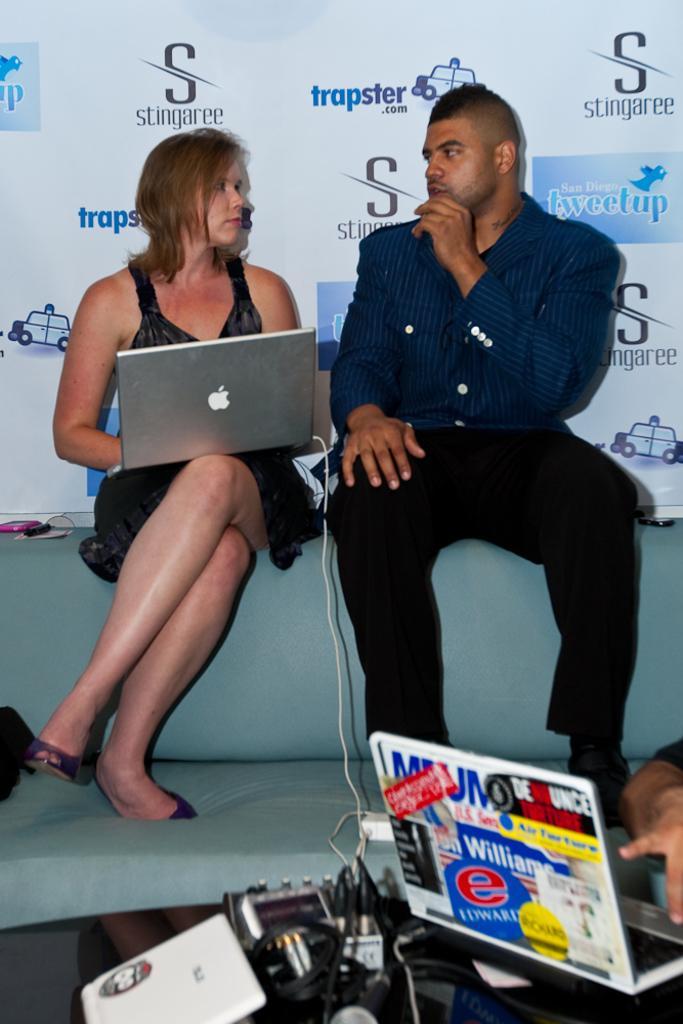Can you describe this image briefly? At the bottom of the image there is a table on which there are objects. There is a laptop. In the center of the image there is a lady sitting on the couch holding a laptop. Beside her there is a person sitting. In the background of the image there is a banner with some text. 